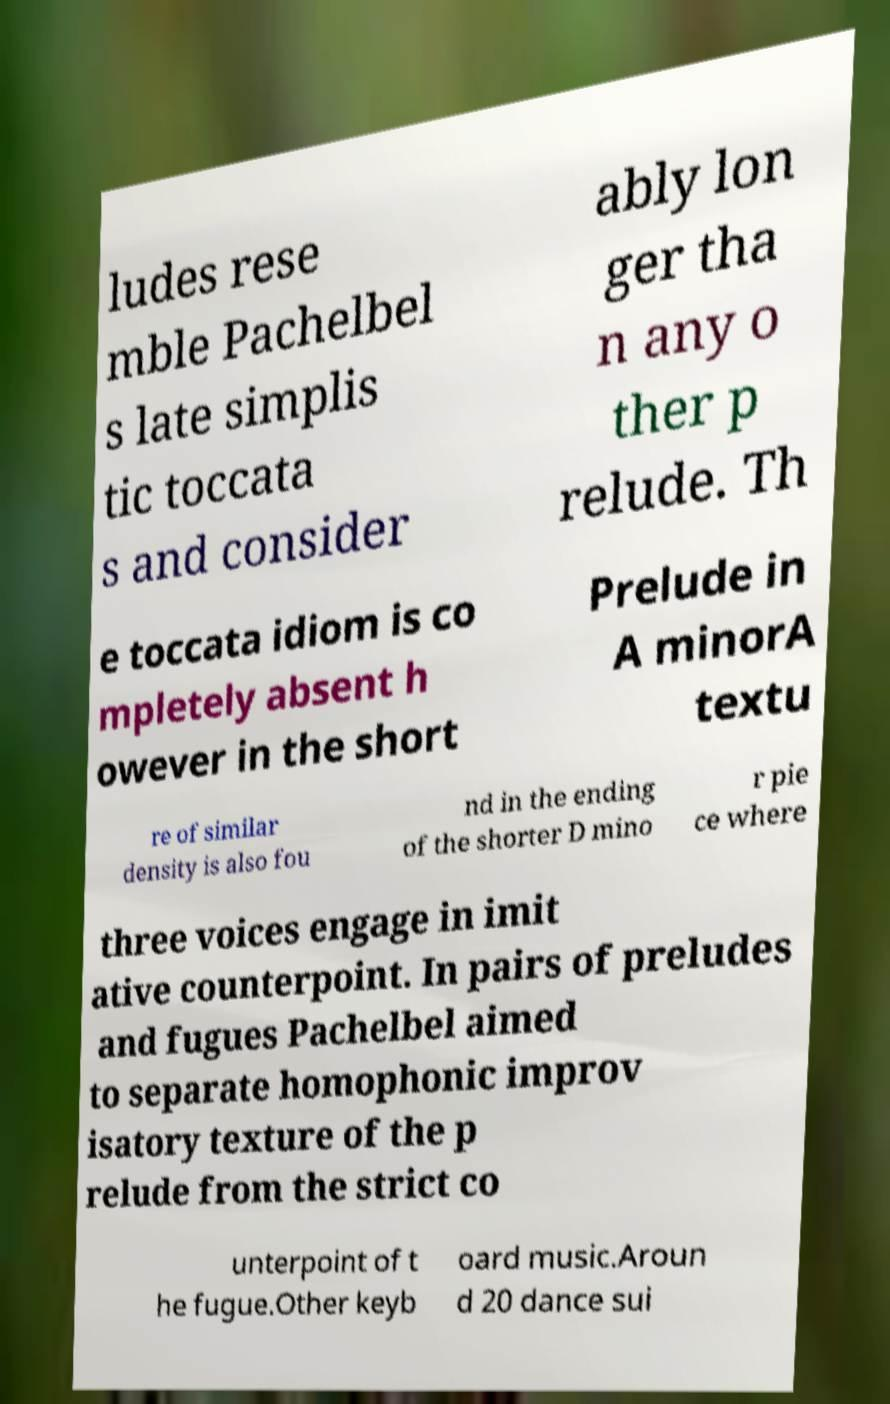Can you accurately transcribe the text from the provided image for me? ludes rese mble Pachelbel s late simplis tic toccata s and consider ably lon ger tha n any o ther p relude. Th e toccata idiom is co mpletely absent h owever in the short Prelude in A minorA textu re of similar density is also fou nd in the ending of the shorter D mino r pie ce where three voices engage in imit ative counterpoint. In pairs of preludes and fugues Pachelbel aimed to separate homophonic improv isatory texture of the p relude from the strict co unterpoint of t he fugue.Other keyb oard music.Aroun d 20 dance sui 